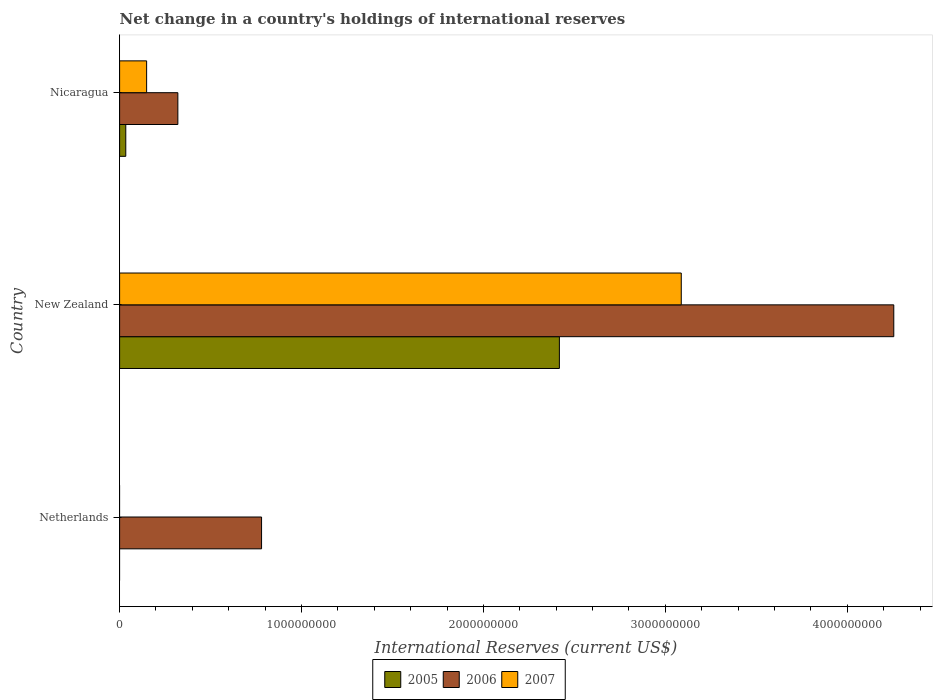How many bars are there on the 3rd tick from the top?
Keep it short and to the point. 1. How many bars are there on the 1st tick from the bottom?
Offer a terse response. 1. What is the label of the 1st group of bars from the top?
Offer a terse response. Nicaragua. What is the international reserves in 2007 in Nicaragua?
Offer a very short reply. 1.49e+08. Across all countries, what is the maximum international reserves in 2005?
Your answer should be compact. 2.42e+09. Across all countries, what is the minimum international reserves in 2007?
Make the answer very short. 0. In which country was the international reserves in 2007 maximum?
Make the answer very short. New Zealand. What is the total international reserves in 2005 in the graph?
Offer a terse response. 2.45e+09. What is the difference between the international reserves in 2005 in New Zealand and that in Nicaragua?
Your response must be concise. 2.38e+09. What is the difference between the international reserves in 2005 in New Zealand and the international reserves in 2007 in Nicaragua?
Give a very brief answer. 2.27e+09. What is the average international reserves in 2005 per country?
Offer a very short reply. 8.17e+08. What is the difference between the international reserves in 2006 and international reserves in 2007 in New Zealand?
Ensure brevity in your answer.  1.17e+09. What is the ratio of the international reserves in 2006 in Netherlands to that in Nicaragua?
Keep it short and to the point. 2.44. What is the difference between the highest and the second highest international reserves in 2006?
Make the answer very short. 3.48e+09. What is the difference between the highest and the lowest international reserves in 2007?
Your answer should be compact. 3.09e+09. In how many countries, is the international reserves in 2006 greater than the average international reserves in 2006 taken over all countries?
Provide a succinct answer. 1. Is the sum of the international reserves in 2006 in Netherlands and Nicaragua greater than the maximum international reserves in 2007 across all countries?
Your response must be concise. No. Is it the case that in every country, the sum of the international reserves in 2007 and international reserves in 2006 is greater than the international reserves in 2005?
Your answer should be compact. Yes. How many countries are there in the graph?
Offer a terse response. 3. What is the difference between two consecutive major ticks on the X-axis?
Ensure brevity in your answer.  1.00e+09. Does the graph contain grids?
Provide a succinct answer. No. How are the legend labels stacked?
Keep it short and to the point. Horizontal. What is the title of the graph?
Provide a short and direct response. Net change in a country's holdings of international reserves. What is the label or title of the X-axis?
Keep it short and to the point. International Reserves (current US$). What is the label or title of the Y-axis?
Your answer should be very brief. Country. What is the International Reserves (current US$) in 2006 in Netherlands?
Offer a terse response. 7.80e+08. What is the International Reserves (current US$) of 2005 in New Zealand?
Your answer should be very brief. 2.42e+09. What is the International Reserves (current US$) in 2006 in New Zealand?
Make the answer very short. 4.26e+09. What is the International Reserves (current US$) in 2007 in New Zealand?
Ensure brevity in your answer.  3.09e+09. What is the International Reserves (current US$) in 2005 in Nicaragua?
Keep it short and to the point. 3.40e+07. What is the International Reserves (current US$) of 2006 in Nicaragua?
Ensure brevity in your answer.  3.20e+08. What is the International Reserves (current US$) in 2007 in Nicaragua?
Your response must be concise. 1.49e+08. Across all countries, what is the maximum International Reserves (current US$) in 2005?
Offer a very short reply. 2.42e+09. Across all countries, what is the maximum International Reserves (current US$) of 2006?
Keep it short and to the point. 4.26e+09. Across all countries, what is the maximum International Reserves (current US$) of 2007?
Ensure brevity in your answer.  3.09e+09. Across all countries, what is the minimum International Reserves (current US$) in 2006?
Give a very brief answer. 3.20e+08. Across all countries, what is the minimum International Reserves (current US$) in 2007?
Your answer should be very brief. 0. What is the total International Reserves (current US$) in 2005 in the graph?
Offer a terse response. 2.45e+09. What is the total International Reserves (current US$) in 2006 in the graph?
Keep it short and to the point. 5.36e+09. What is the total International Reserves (current US$) of 2007 in the graph?
Provide a short and direct response. 3.24e+09. What is the difference between the International Reserves (current US$) in 2006 in Netherlands and that in New Zealand?
Your answer should be very brief. -3.48e+09. What is the difference between the International Reserves (current US$) in 2006 in Netherlands and that in Nicaragua?
Make the answer very short. 4.60e+08. What is the difference between the International Reserves (current US$) in 2005 in New Zealand and that in Nicaragua?
Provide a short and direct response. 2.38e+09. What is the difference between the International Reserves (current US$) in 2006 in New Zealand and that in Nicaragua?
Provide a succinct answer. 3.94e+09. What is the difference between the International Reserves (current US$) of 2007 in New Zealand and that in Nicaragua?
Provide a succinct answer. 2.94e+09. What is the difference between the International Reserves (current US$) in 2006 in Netherlands and the International Reserves (current US$) in 2007 in New Zealand?
Keep it short and to the point. -2.31e+09. What is the difference between the International Reserves (current US$) in 2006 in Netherlands and the International Reserves (current US$) in 2007 in Nicaragua?
Keep it short and to the point. 6.32e+08. What is the difference between the International Reserves (current US$) in 2005 in New Zealand and the International Reserves (current US$) in 2006 in Nicaragua?
Your answer should be very brief. 2.10e+09. What is the difference between the International Reserves (current US$) of 2005 in New Zealand and the International Reserves (current US$) of 2007 in Nicaragua?
Ensure brevity in your answer.  2.27e+09. What is the difference between the International Reserves (current US$) of 2006 in New Zealand and the International Reserves (current US$) of 2007 in Nicaragua?
Your response must be concise. 4.11e+09. What is the average International Reserves (current US$) in 2005 per country?
Ensure brevity in your answer.  8.17e+08. What is the average International Reserves (current US$) in 2006 per country?
Ensure brevity in your answer.  1.79e+09. What is the average International Reserves (current US$) in 2007 per country?
Your answer should be compact. 1.08e+09. What is the difference between the International Reserves (current US$) in 2005 and International Reserves (current US$) in 2006 in New Zealand?
Your response must be concise. -1.84e+09. What is the difference between the International Reserves (current US$) in 2005 and International Reserves (current US$) in 2007 in New Zealand?
Your response must be concise. -6.70e+08. What is the difference between the International Reserves (current US$) in 2006 and International Reserves (current US$) in 2007 in New Zealand?
Offer a terse response. 1.17e+09. What is the difference between the International Reserves (current US$) of 2005 and International Reserves (current US$) of 2006 in Nicaragua?
Give a very brief answer. -2.86e+08. What is the difference between the International Reserves (current US$) in 2005 and International Reserves (current US$) in 2007 in Nicaragua?
Make the answer very short. -1.15e+08. What is the difference between the International Reserves (current US$) of 2006 and International Reserves (current US$) of 2007 in Nicaragua?
Provide a succinct answer. 1.72e+08. What is the ratio of the International Reserves (current US$) of 2006 in Netherlands to that in New Zealand?
Offer a very short reply. 0.18. What is the ratio of the International Reserves (current US$) of 2006 in Netherlands to that in Nicaragua?
Ensure brevity in your answer.  2.44. What is the ratio of the International Reserves (current US$) of 2005 in New Zealand to that in Nicaragua?
Your answer should be very brief. 71.2. What is the ratio of the International Reserves (current US$) in 2006 in New Zealand to that in Nicaragua?
Your answer should be compact. 13.29. What is the ratio of the International Reserves (current US$) of 2007 in New Zealand to that in Nicaragua?
Your response must be concise. 20.78. What is the difference between the highest and the second highest International Reserves (current US$) in 2006?
Your answer should be very brief. 3.48e+09. What is the difference between the highest and the lowest International Reserves (current US$) in 2005?
Your response must be concise. 2.42e+09. What is the difference between the highest and the lowest International Reserves (current US$) of 2006?
Give a very brief answer. 3.94e+09. What is the difference between the highest and the lowest International Reserves (current US$) in 2007?
Give a very brief answer. 3.09e+09. 